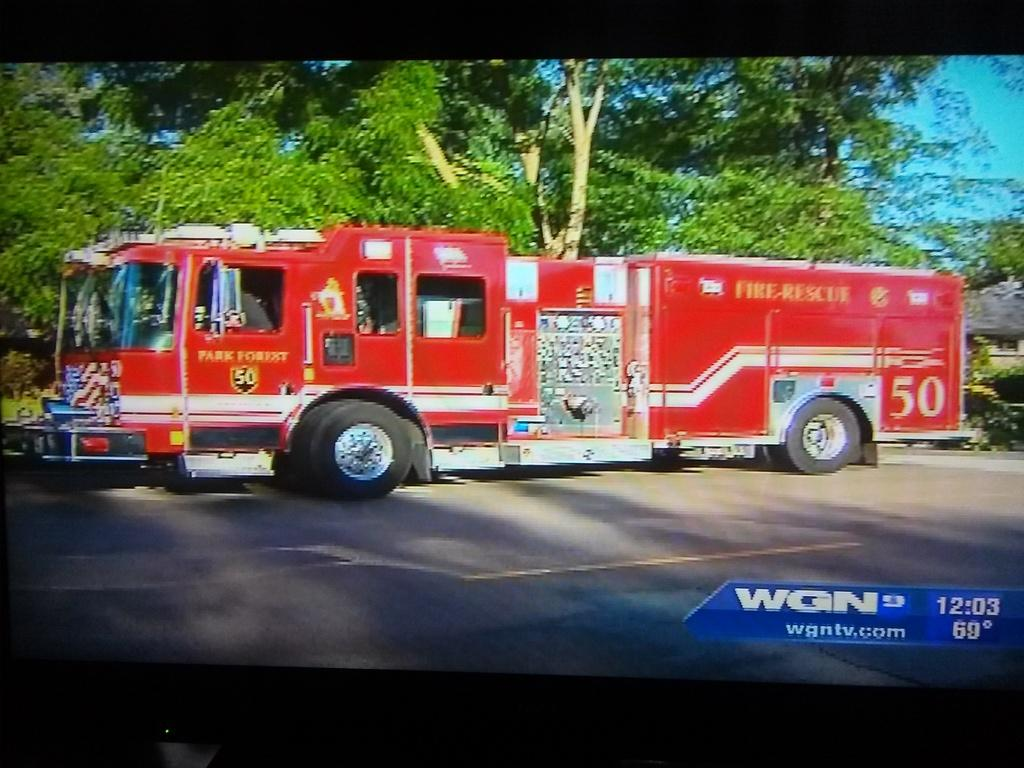What type of vehicle is in the image? There is a fire engine vehicle in the image. Where is the vehicle located? The vehicle is standing on the road. What can be seen in the background of the image? There are trees visible in the background of the image. How does the fire engine vehicle provide comfort to the trees in the image? The fire engine vehicle does not provide comfort to the trees in the image; it is a vehicle designed for firefighting and rescue operations. 